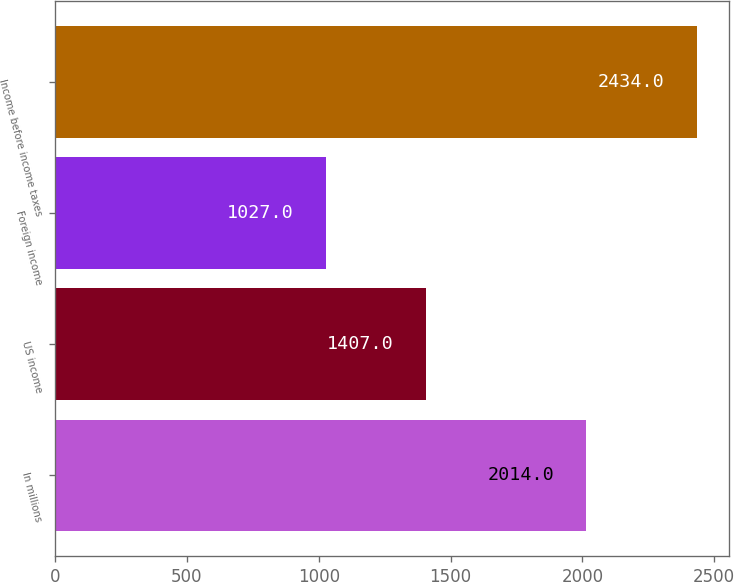Convert chart. <chart><loc_0><loc_0><loc_500><loc_500><bar_chart><fcel>In millions<fcel>US income<fcel>Foreign income<fcel>Income before income taxes<nl><fcel>2014<fcel>1407<fcel>1027<fcel>2434<nl></chart> 